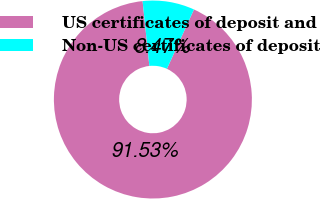Convert chart. <chart><loc_0><loc_0><loc_500><loc_500><pie_chart><fcel>US certificates of deposit and<fcel>Non-US certificates of deposit<nl><fcel>91.53%<fcel>8.47%<nl></chart> 